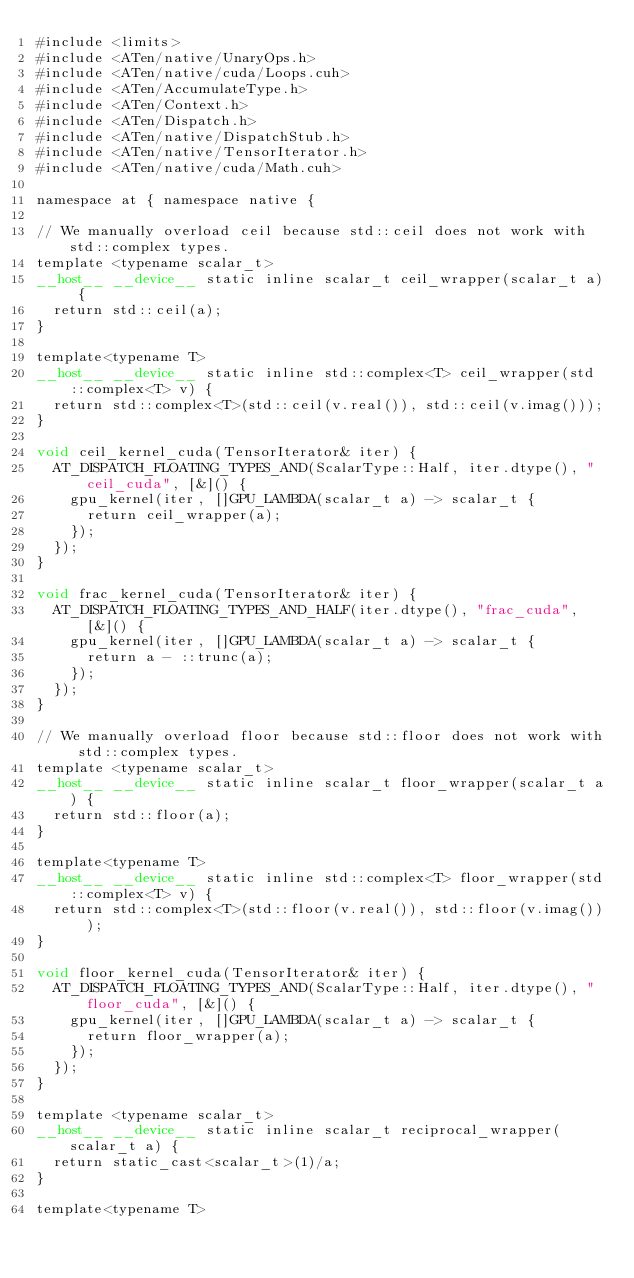Convert code to text. <code><loc_0><loc_0><loc_500><loc_500><_Cuda_>#include <limits>
#include <ATen/native/UnaryOps.h>
#include <ATen/native/cuda/Loops.cuh>
#include <ATen/AccumulateType.h>
#include <ATen/Context.h>
#include <ATen/Dispatch.h>
#include <ATen/native/DispatchStub.h>
#include <ATen/native/TensorIterator.h>
#include <ATen/native/cuda/Math.cuh>

namespace at { namespace native {

// We manually overload ceil because std::ceil does not work with std::complex types.
template <typename scalar_t>
__host__ __device__ static inline scalar_t ceil_wrapper(scalar_t a) {
  return std::ceil(a);
}

template<typename T>
__host__ __device__ static inline std::complex<T> ceil_wrapper(std::complex<T> v) {
  return std::complex<T>(std::ceil(v.real()), std::ceil(v.imag()));
}

void ceil_kernel_cuda(TensorIterator& iter) {
  AT_DISPATCH_FLOATING_TYPES_AND(ScalarType::Half, iter.dtype(), "ceil_cuda", [&]() {
    gpu_kernel(iter, []GPU_LAMBDA(scalar_t a) -> scalar_t {
      return ceil_wrapper(a);
    });
  });
}

void frac_kernel_cuda(TensorIterator& iter) {
  AT_DISPATCH_FLOATING_TYPES_AND_HALF(iter.dtype(), "frac_cuda", [&]() {
    gpu_kernel(iter, []GPU_LAMBDA(scalar_t a) -> scalar_t {
      return a - ::trunc(a);
    });
  });
}

// We manually overload floor because std::floor does not work with std::complex types.
template <typename scalar_t>
__host__ __device__ static inline scalar_t floor_wrapper(scalar_t a) {
  return std::floor(a);
}

template<typename T>
__host__ __device__ static inline std::complex<T> floor_wrapper(std::complex<T> v) {
  return std::complex<T>(std::floor(v.real()), std::floor(v.imag()));
}

void floor_kernel_cuda(TensorIterator& iter) {
  AT_DISPATCH_FLOATING_TYPES_AND(ScalarType::Half, iter.dtype(), "floor_cuda", [&]() {
    gpu_kernel(iter, []GPU_LAMBDA(scalar_t a) -> scalar_t {
      return floor_wrapper(a);
    });
  });
}

template <typename scalar_t>
__host__ __device__ static inline scalar_t reciprocal_wrapper(scalar_t a) {
  return static_cast<scalar_t>(1)/a;
}

template<typename T></code> 